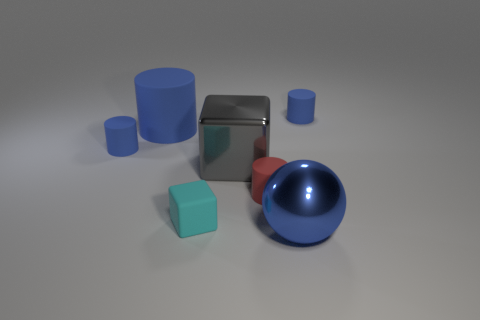There is a block that is the same size as the ball; what is its color?
Keep it short and to the point. Gray. Is the shape of the big gray metallic thing the same as the cyan thing?
Your answer should be compact. Yes. There is a blue thing in front of the tiny red cylinder; what is its material?
Your answer should be compact. Metal. The big shiny sphere is what color?
Offer a terse response. Blue. Do the blue rubber object to the right of the metallic block and the blue object that is in front of the metal cube have the same size?
Keep it short and to the point. No. How big is the blue thing that is on the right side of the big cylinder and behind the tiny cyan thing?
Make the answer very short. Small. There is another big rubber thing that is the same shape as the red rubber object; what color is it?
Keep it short and to the point. Blue. Are there more rubber things to the right of the red object than big gray metallic things that are to the right of the gray shiny block?
Your answer should be very brief. Yes. What number of other things are there of the same shape as the big rubber object?
Your answer should be compact. 3. There is a large blue rubber cylinder that is behind the tiny cyan rubber block; is there a big rubber cylinder that is to the left of it?
Provide a succinct answer. No. 